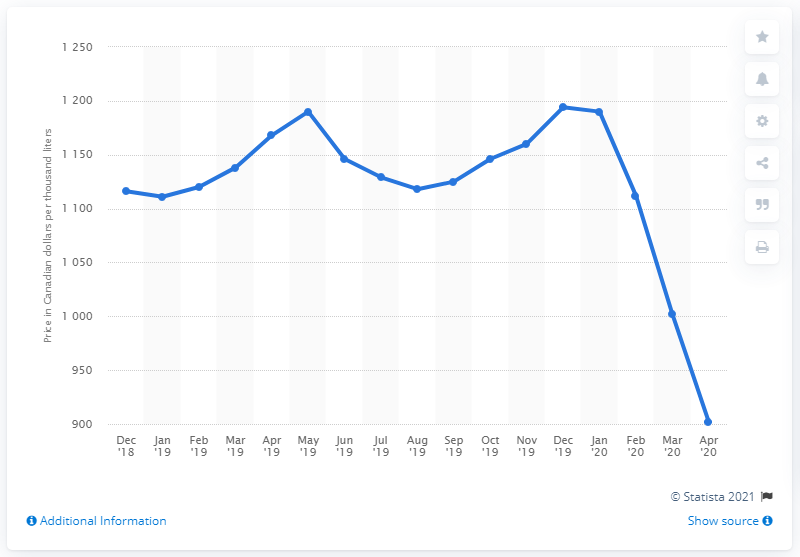Point out several critical features in this image. The average domestic heating oil price in Canada during April 2020 was 902. 